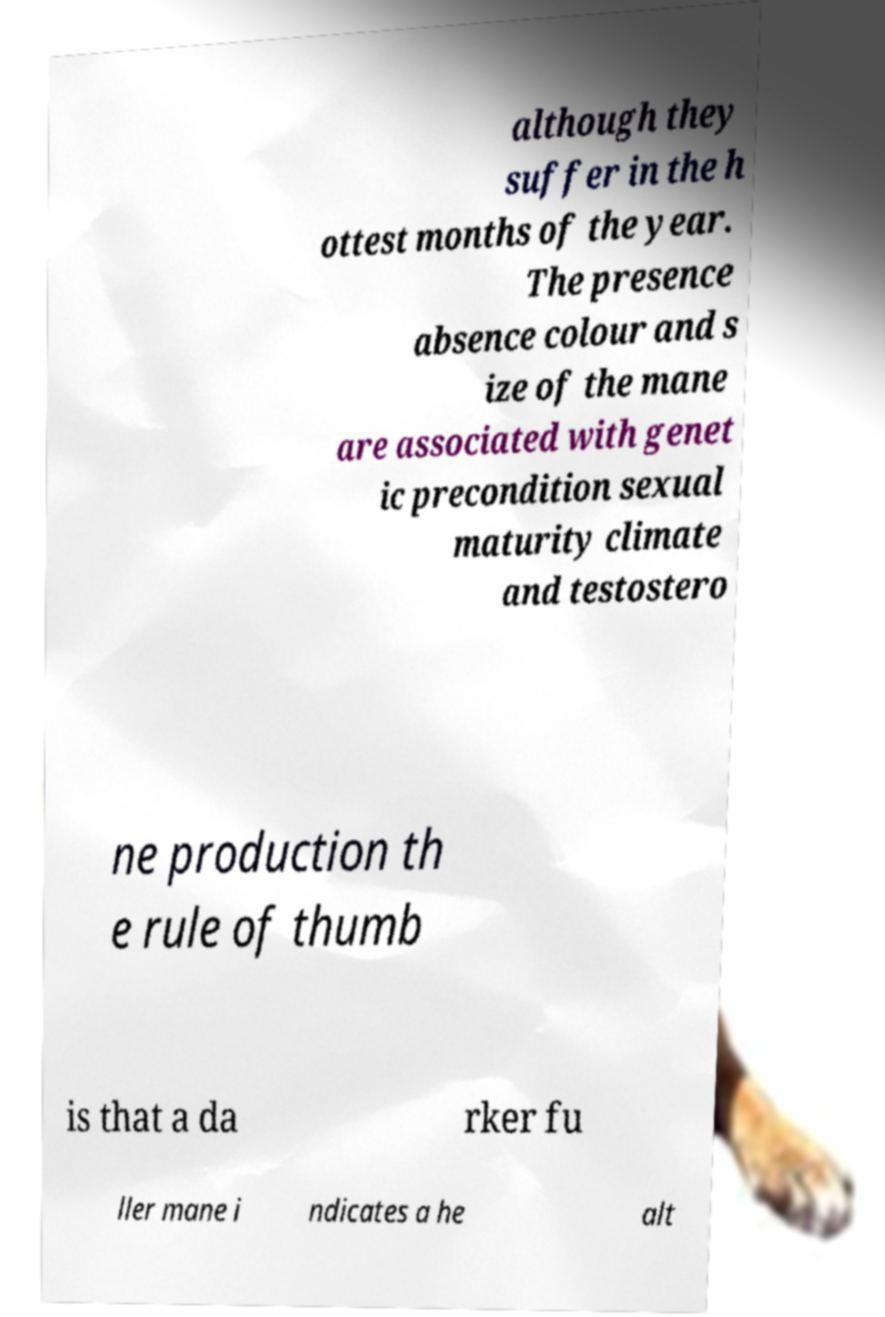For documentation purposes, I need the text within this image transcribed. Could you provide that? although they suffer in the h ottest months of the year. The presence absence colour and s ize of the mane are associated with genet ic precondition sexual maturity climate and testostero ne production th e rule of thumb is that a da rker fu ller mane i ndicates a he alt 